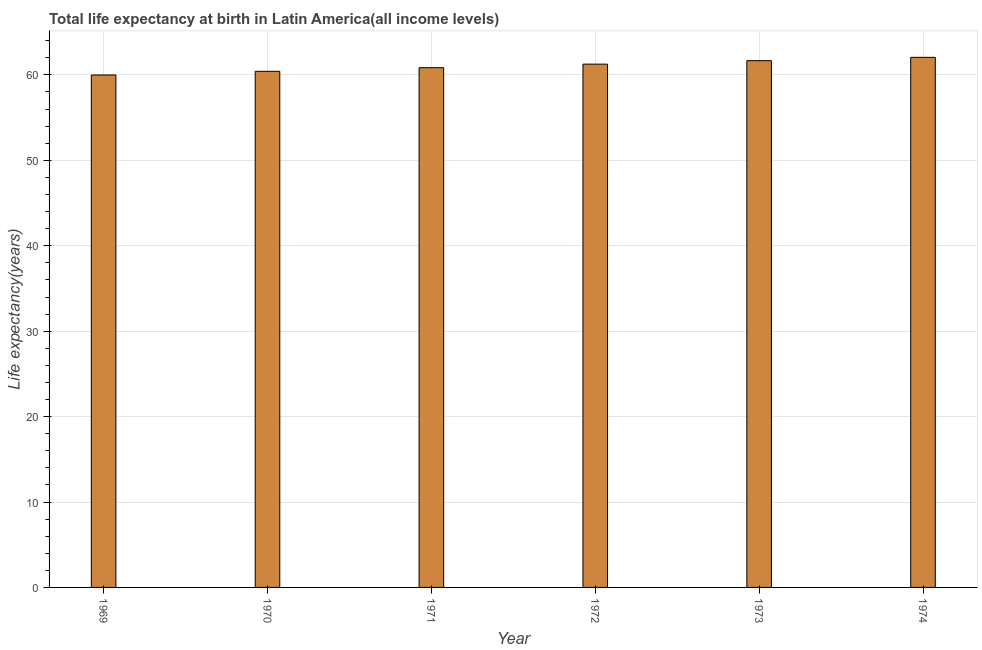Does the graph contain any zero values?
Keep it short and to the point. No. What is the title of the graph?
Your answer should be compact. Total life expectancy at birth in Latin America(all income levels). What is the label or title of the X-axis?
Make the answer very short. Year. What is the label or title of the Y-axis?
Your answer should be compact. Life expectancy(years). What is the life expectancy at birth in 1971?
Make the answer very short. 60.85. Across all years, what is the maximum life expectancy at birth?
Ensure brevity in your answer.  62.06. Across all years, what is the minimum life expectancy at birth?
Offer a terse response. 59.99. In which year was the life expectancy at birth maximum?
Your answer should be compact. 1974. In which year was the life expectancy at birth minimum?
Offer a very short reply. 1969. What is the sum of the life expectancy at birth?
Ensure brevity in your answer.  366.25. What is the difference between the life expectancy at birth in 1969 and 1974?
Provide a succinct answer. -2.07. What is the average life expectancy at birth per year?
Your answer should be very brief. 61.04. What is the median life expectancy at birth?
Give a very brief answer. 61.05. Do a majority of the years between 1973 and 1970 (inclusive) have life expectancy at birth greater than 34 years?
Your answer should be very brief. Yes. What is the ratio of the life expectancy at birth in 1971 to that in 1973?
Your answer should be compact. 0.99. Is the life expectancy at birth in 1969 less than that in 1970?
Make the answer very short. Yes. What is the difference between the highest and the second highest life expectancy at birth?
Your response must be concise. 0.39. What is the difference between the highest and the lowest life expectancy at birth?
Your response must be concise. 2.07. How many bars are there?
Your answer should be very brief. 6. How many years are there in the graph?
Your answer should be compact. 6. What is the Life expectancy(years) of 1969?
Provide a succinct answer. 59.99. What is the Life expectancy(years) of 1970?
Offer a very short reply. 60.42. What is the Life expectancy(years) of 1971?
Give a very brief answer. 60.85. What is the Life expectancy(years) of 1972?
Provide a succinct answer. 61.26. What is the Life expectancy(years) of 1973?
Offer a terse response. 61.67. What is the Life expectancy(years) of 1974?
Your response must be concise. 62.06. What is the difference between the Life expectancy(years) in 1969 and 1970?
Make the answer very short. -0.43. What is the difference between the Life expectancy(years) in 1969 and 1971?
Your answer should be very brief. -0.85. What is the difference between the Life expectancy(years) in 1969 and 1972?
Give a very brief answer. -1.27. What is the difference between the Life expectancy(years) in 1969 and 1973?
Keep it short and to the point. -1.68. What is the difference between the Life expectancy(years) in 1969 and 1974?
Provide a short and direct response. -2.07. What is the difference between the Life expectancy(years) in 1970 and 1971?
Offer a very short reply. -0.43. What is the difference between the Life expectancy(years) in 1970 and 1972?
Provide a succinct answer. -0.84. What is the difference between the Life expectancy(years) in 1970 and 1973?
Offer a very short reply. -1.25. What is the difference between the Life expectancy(years) in 1970 and 1974?
Keep it short and to the point. -1.64. What is the difference between the Life expectancy(years) in 1971 and 1972?
Keep it short and to the point. -0.42. What is the difference between the Life expectancy(years) in 1971 and 1973?
Ensure brevity in your answer.  -0.82. What is the difference between the Life expectancy(years) in 1971 and 1974?
Keep it short and to the point. -1.21. What is the difference between the Life expectancy(years) in 1972 and 1973?
Keep it short and to the point. -0.4. What is the difference between the Life expectancy(years) in 1972 and 1974?
Offer a very short reply. -0.8. What is the difference between the Life expectancy(years) in 1973 and 1974?
Ensure brevity in your answer.  -0.39. What is the ratio of the Life expectancy(years) in 1969 to that in 1972?
Keep it short and to the point. 0.98. What is the ratio of the Life expectancy(years) in 1970 to that in 1971?
Provide a short and direct response. 0.99. What is the ratio of the Life expectancy(years) in 1970 to that in 1974?
Your response must be concise. 0.97. What is the ratio of the Life expectancy(years) in 1972 to that in 1973?
Your answer should be compact. 0.99. What is the ratio of the Life expectancy(years) in 1972 to that in 1974?
Provide a short and direct response. 0.99. 